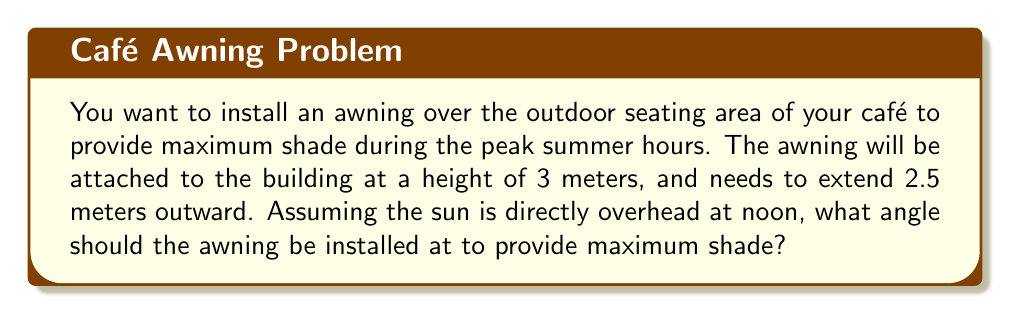Give your solution to this math problem. To solve this problem, we'll use trigonometry. We need to find the angle that creates the largest shadow when the sun is directly overhead.

1) Let's visualize the scenario:
   [asy]
   unitsize(1cm);
   pair A = (0,0), B = (2.5,0), C = (0,3);
   draw(A--B--C--cycle);
   label("3m", C--A, W);
   label("2.5m", A--B, S);
   label("$\theta$", A, NE);
   draw(rightanglemark(B,A,C));
   [/asy]

2) We have a right triangle where:
   - The vertical side (building height) is 3 meters
   - The horizontal side (awning extension) is 2.5 meters
   - We need to find the angle $\theta$

3) We can use the arctangent function to find this angle:

   $$\theta = \arctan(\frac{\text{opposite}}{\text{adjacent}}) = \arctan(\frac{3}{2.5})$$

4) Calculate:
   $$\theta = \arctan(\frac{3}{2.5}) \approx 50.19°$$

5) To maximize shade, we want the awning to be perpendicular to the sun's rays. Since the sun is directly overhead, we need to subtract this angle from 90°:

   $$\text{Optimal angle} = 90° - 50.19° \approx 39.81°$$

Therefore, the optimal angle for the awning is approximately 39.81° from the horizontal.
Answer: $39.81°$ 